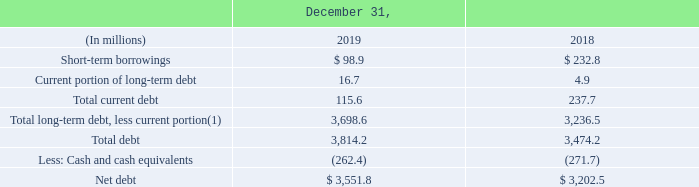Outstanding Indebtedness
At December 31, 2019 and 2018, our total debt outstanding consisted of the amounts set forth in the following table.
(1) Amounts are net of unamortized discounts and debt issuance costs of $25 million and $24 million as of December 31, 2019 and 2018, respectively. See Note 14, “Debt and Credit Facilities,” of the Notes to Consolidated Financial Statements for further details.
For Total long-term debt, less current portion in 2019, what is the net of unamortized discounts and debt issuance cost? $25 million. For what years of Outstanding Indebtedness are shown in the table?  2018, 2019. What unit is the table expressed by? In millions. What is the percentage change of Net debt from 2018 to 2019?
Answer scale should be: percent. (3,551.8-3,202.5)/3,202.5
Answer: 10.91. What is the average annual Total debt for years 2018 and 2019?
Answer scale should be: million. (3,814.2+3,474.2)/2
Answer: 3644.2. What is the Total long-term debt, less current portion for 2019, without accounting for unamortized discounts and debt issuance costs?
Answer scale should be: million. 3,698.6-25
Answer: 3673.6. 